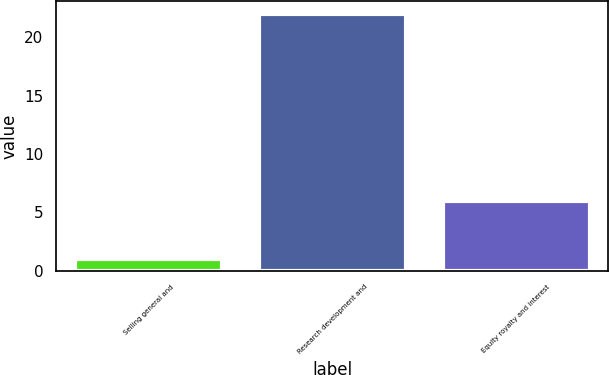Convert chart. <chart><loc_0><loc_0><loc_500><loc_500><bar_chart><fcel>Selling general and<fcel>Research development and<fcel>Equity royalty and interest<nl><fcel>1<fcel>22<fcel>6<nl></chart> 